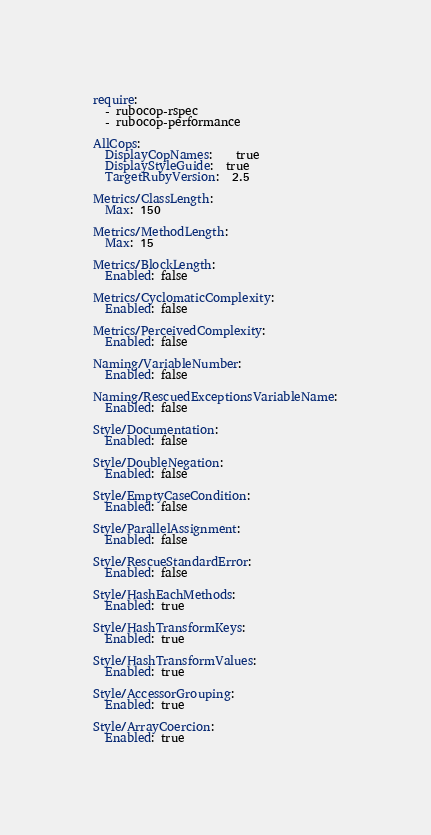<code> <loc_0><loc_0><loc_500><loc_500><_YAML_>require:
  - rubocop-rspec
  - rubocop-performance

AllCops:
  DisplayCopNames:    true
  DisplayStyleGuide:  true
  TargetRubyVersion:  2.5

Metrics/ClassLength:
  Max: 150

Metrics/MethodLength:
  Max: 15

Metrics/BlockLength:
  Enabled: false

Metrics/CyclomaticComplexity:
  Enabled: false

Metrics/PerceivedComplexity:
  Enabled: false

Naming/VariableNumber:
  Enabled: false

Naming/RescuedExceptionsVariableName:
  Enabled: false

Style/Documentation:
  Enabled: false

Style/DoubleNegation:
  Enabled: false

Style/EmptyCaseCondition:
  Enabled: false

Style/ParallelAssignment:
  Enabled: false

Style/RescueStandardError:
  Enabled: false

Style/HashEachMethods:
  Enabled: true

Style/HashTransformKeys:
  Enabled: true

Style/HashTransformValues:
  Enabled: true

Style/AccessorGrouping:
  Enabled: true

Style/ArrayCoercion:
  Enabled: true
</code> 